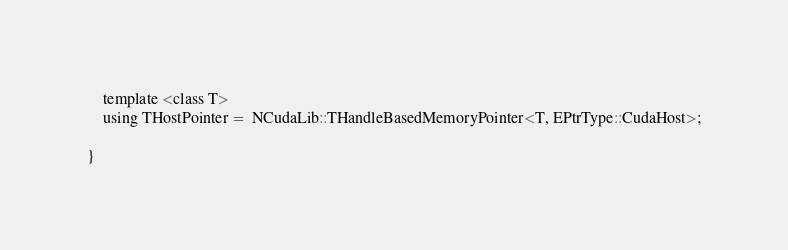<code> <loc_0><loc_0><loc_500><loc_500><_Cuda_>
    template <class T>
    using THostPointer =  NCudaLib::THandleBasedMemoryPointer<T, EPtrType::CudaHost>;

}
</code> 